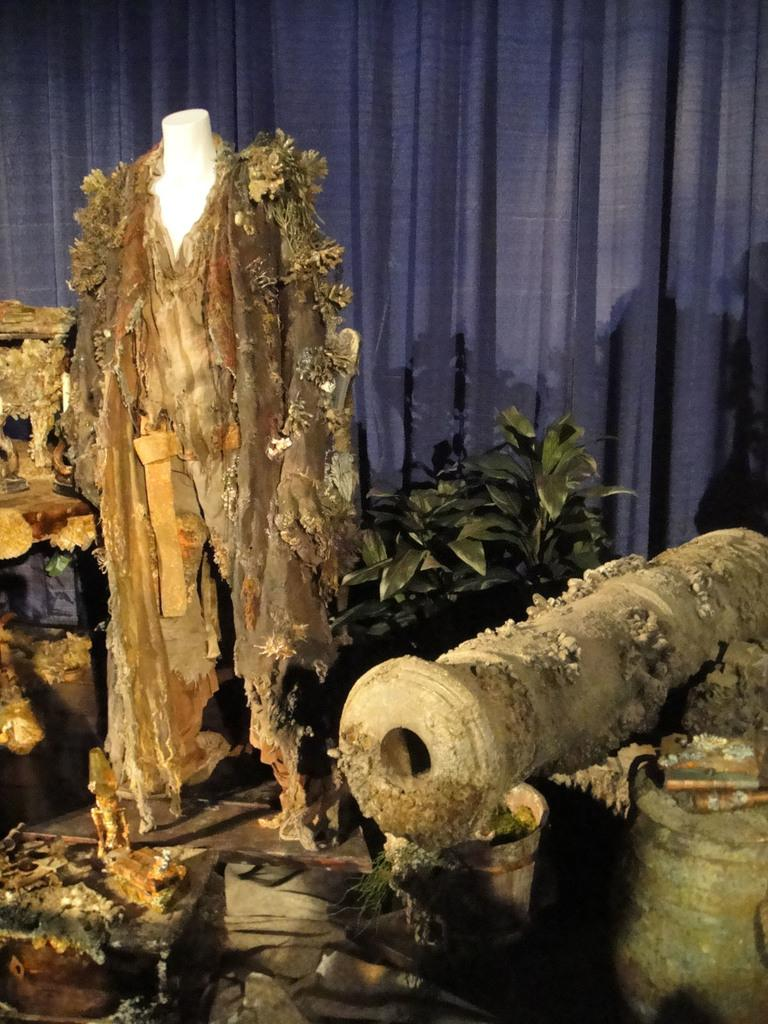What is the main subject in the image? There is a mannequin in the image. What type of living organisms can be seen in the image? There are plants in the image. What type of window treatment is present in the image? There are curtains in the image. What degree does the mannequin have in the image? The mannequin does not have a degree, as it is an inanimate object and not a person. What type of weather can be seen in the image? There is no indication of weather in the image, as it only features a mannequin, plants, and curtains. 